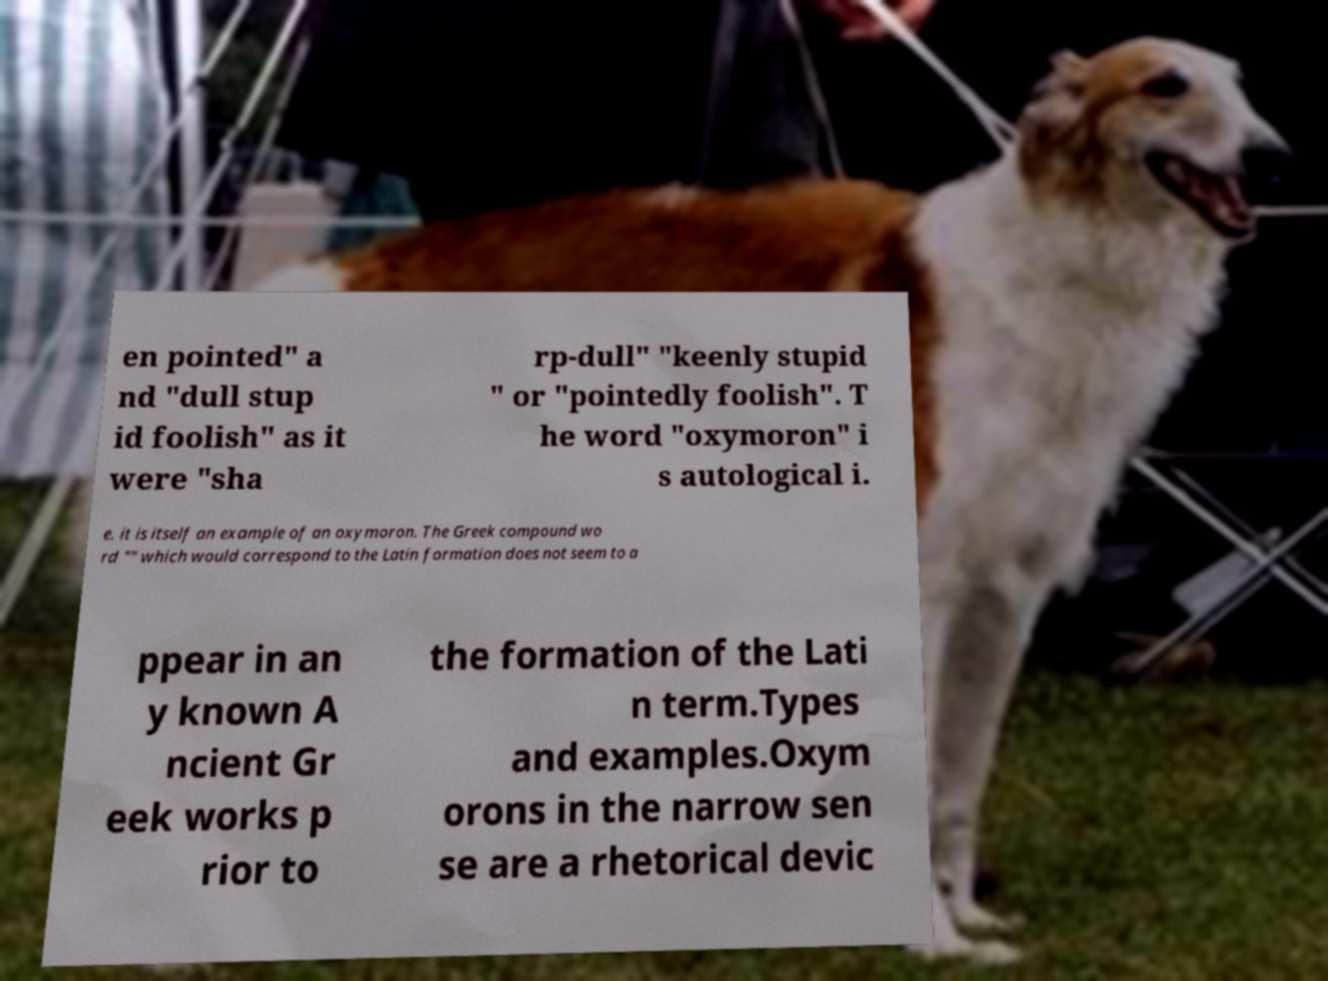Please identify and transcribe the text found in this image. en pointed" a nd "dull stup id foolish" as it were "sha rp-dull" "keenly stupid " or "pointedly foolish". T he word "oxymoron" i s autological i. e. it is itself an example of an oxymoron. The Greek compound wo rd "" which would correspond to the Latin formation does not seem to a ppear in an y known A ncient Gr eek works p rior to the formation of the Lati n term.Types and examples.Oxym orons in the narrow sen se are a rhetorical devic 